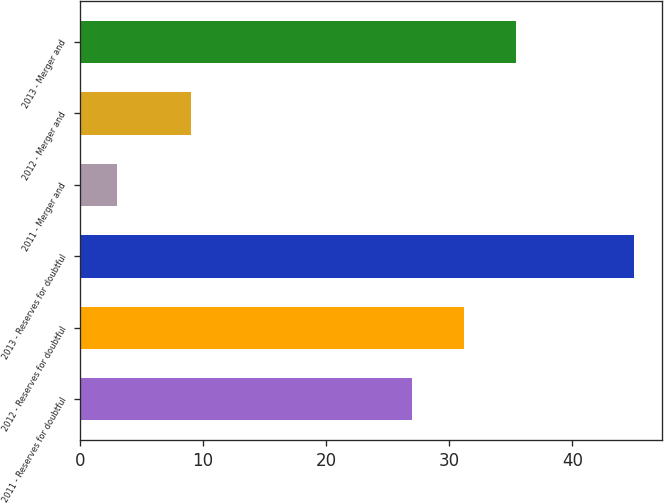Convert chart to OTSL. <chart><loc_0><loc_0><loc_500><loc_500><bar_chart><fcel>2011 - Reserves for doubtful<fcel>2012 - Reserves for doubtful<fcel>2013 - Reserves for doubtful<fcel>2011 - Merger and<fcel>2012 - Merger and<fcel>2013 - Merger and<nl><fcel>27<fcel>31.2<fcel>45<fcel>3<fcel>9<fcel>35.4<nl></chart> 